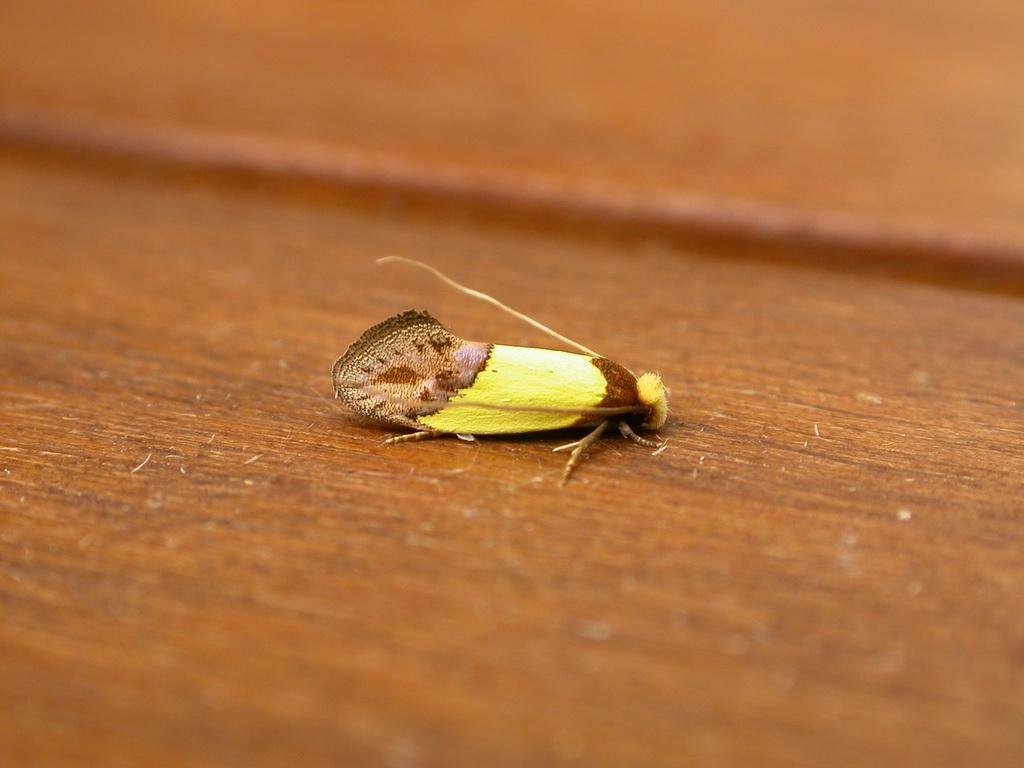What type of creature is present in the image? There is an insect in the image. What colors can be seen on the insect? The insect has yellow and brown colors. Where is the insect located in the image? The insect is on a brown carpet. How would you describe the background of the image? The background of the image is brown and blurred. What type of feast is being prepared in the image? There is no feast present in the image; it features an insect on a brown carpet. Can you see a pencil being used by the insect in the image? There is no pencil visible in the image, and insects do not use pencils. 